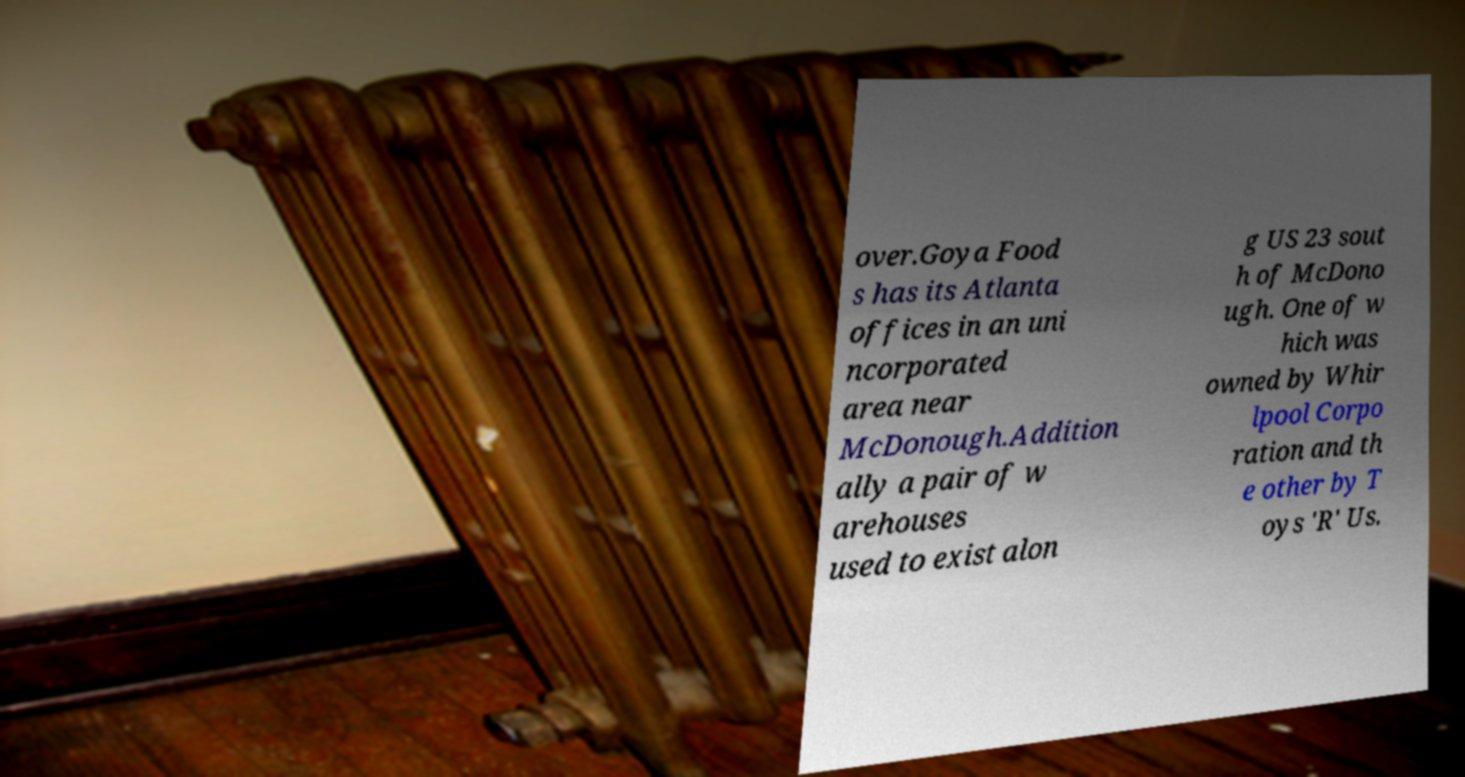Please identify and transcribe the text found in this image. over.Goya Food s has its Atlanta offices in an uni ncorporated area near McDonough.Addition ally a pair of w arehouses used to exist alon g US 23 sout h of McDono ugh. One of w hich was owned by Whir lpool Corpo ration and th e other by T oys 'R' Us. 